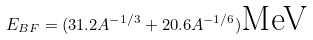<formula> <loc_0><loc_0><loc_500><loc_500>E _ { B F } = ( 3 1 . 2 A ^ { - 1 / 3 } + 2 0 . 6 A ^ { - 1 / 6 } ) \text {MeV}</formula> 